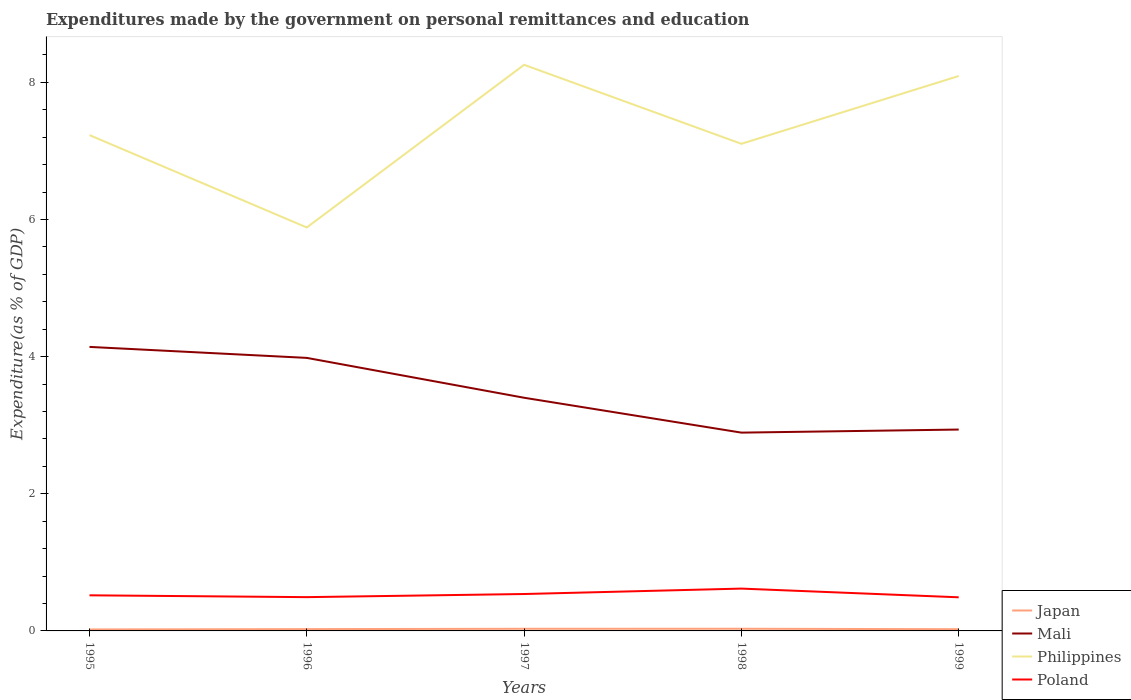How many different coloured lines are there?
Your response must be concise. 4. Does the line corresponding to Japan intersect with the line corresponding to Mali?
Make the answer very short. No. Across all years, what is the maximum expenditures made by the government on personal remittances and education in Philippines?
Keep it short and to the point. 5.88. What is the total expenditures made by the government on personal remittances and education in Philippines in the graph?
Your answer should be very brief. 0.13. What is the difference between the highest and the second highest expenditures made by the government on personal remittances and education in Mali?
Offer a terse response. 1.25. How many legend labels are there?
Your response must be concise. 4. What is the title of the graph?
Your response must be concise. Expenditures made by the government on personal remittances and education. What is the label or title of the X-axis?
Your answer should be very brief. Years. What is the label or title of the Y-axis?
Your response must be concise. Expenditure(as % of GDP). What is the Expenditure(as % of GDP) of Japan in 1995?
Provide a short and direct response. 0.02. What is the Expenditure(as % of GDP) of Mali in 1995?
Provide a short and direct response. 4.14. What is the Expenditure(as % of GDP) of Philippines in 1995?
Your response must be concise. 7.23. What is the Expenditure(as % of GDP) in Poland in 1995?
Ensure brevity in your answer.  0.52. What is the Expenditure(as % of GDP) of Japan in 1996?
Your response must be concise. 0.03. What is the Expenditure(as % of GDP) of Mali in 1996?
Ensure brevity in your answer.  3.98. What is the Expenditure(as % of GDP) in Philippines in 1996?
Ensure brevity in your answer.  5.88. What is the Expenditure(as % of GDP) of Poland in 1996?
Offer a very short reply. 0.49. What is the Expenditure(as % of GDP) of Japan in 1997?
Your answer should be very brief. 0.03. What is the Expenditure(as % of GDP) of Mali in 1997?
Provide a succinct answer. 3.4. What is the Expenditure(as % of GDP) in Philippines in 1997?
Offer a very short reply. 8.26. What is the Expenditure(as % of GDP) in Poland in 1997?
Give a very brief answer. 0.54. What is the Expenditure(as % of GDP) in Japan in 1998?
Provide a succinct answer. 0.03. What is the Expenditure(as % of GDP) in Mali in 1998?
Make the answer very short. 2.89. What is the Expenditure(as % of GDP) in Philippines in 1998?
Provide a short and direct response. 7.1. What is the Expenditure(as % of GDP) of Poland in 1998?
Your response must be concise. 0.62. What is the Expenditure(as % of GDP) in Japan in 1999?
Keep it short and to the point. 0.03. What is the Expenditure(as % of GDP) in Mali in 1999?
Your response must be concise. 2.94. What is the Expenditure(as % of GDP) in Philippines in 1999?
Provide a short and direct response. 8.09. What is the Expenditure(as % of GDP) in Poland in 1999?
Provide a short and direct response. 0.49. Across all years, what is the maximum Expenditure(as % of GDP) of Japan?
Give a very brief answer. 0.03. Across all years, what is the maximum Expenditure(as % of GDP) in Mali?
Your answer should be very brief. 4.14. Across all years, what is the maximum Expenditure(as % of GDP) of Philippines?
Offer a very short reply. 8.26. Across all years, what is the maximum Expenditure(as % of GDP) of Poland?
Your response must be concise. 0.62. Across all years, what is the minimum Expenditure(as % of GDP) of Japan?
Ensure brevity in your answer.  0.02. Across all years, what is the minimum Expenditure(as % of GDP) in Mali?
Keep it short and to the point. 2.89. Across all years, what is the minimum Expenditure(as % of GDP) of Philippines?
Give a very brief answer. 5.88. Across all years, what is the minimum Expenditure(as % of GDP) in Poland?
Provide a succinct answer. 0.49. What is the total Expenditure(as % of GDP) in Japan in the graph?
Provide a succinct answer. 0.14. What is the total Expenditure(as % of GDP) of Mali in the graph?
Give a very brief answer. 17.35. What is the total Expenditure(as % of GDP) of Philippines in the graph?
Provide a succinct answer. 36.57. What is the total Expenditure(as % of GDP) of Poland in the graph?
Your response must be concise. 2.66. What is the difference between the Expenditure(as % of GDP) of Japan in 1995 and that in 1996?
Your answer should be very brief. -0. What is the difference between the Expenditure(as % of GDP) of Mali in 1995 and that in 1996?
Your response must be concise. 0.16. What is the difference between the Expenditure(as % of GDP) in Philippines in 1995 and that in 1996?
Your answer should be compact. 1.35. What is the difference between the Expenditure(as % of GDP) in Poland in 1995 and that in 1996?
Give a very brief answer. 0.03. What is the difference between the Expenditure(as % of GDP) of Japan in 1995 and that in 1997?
Provide a succinct answer. -0.01. What is the difference between the Expenditure(as % of GDP) in Mali in 1995 and that in 1997?
Make the answer very short. 0.74. What is the difference between the Expenditure(as % of GDP) in Philippines in 1995 and that in 1997?
Make the answer very short. -1.03. What is the difference between the Expenditure(as % of GDP) of Poland in 1995 and that in 1997?
Your answer should be very brief. -0.02. What is the difference between the Expenditure(as % of GDP) in Japan in 1995 and that in 1998?
Make the answer very short. -0.01. What is the difference between the Expenditure(as % of GDP) in Mali in 1995 and that in 1998?
Your response must be concise. 1.25. What is the difference between the Expenditure(as % of GDP) of Philippines in 1995 and that in 1998?
Make the answer very short. 0.13. What is the difference between the Expenditure(as % of GDP) of Poland in 1995 and that in 1998?
Make the answer very short. -0.1. What is the difference between the Expenditure(as % of GDP) in Japan in 1995 and that in 1999?
Offer a very short reply. -0. What is the difference between the Expenditure(as % of GDP) of Mali in 1995 and that in 1999?
Provide a short and direct response. 1.21. What is the difference between the Expenditure(as % of GDP) in Philippines in 1995 and that in 1999?
Provide a short and direct response. -0.86. What is the difference between the Expenditure(as % of GDP) in Poland in 1995 and that in 1999?
Provide a short and direct response. 0.03. What is the difference between the Expenditure(as % of GDP) in Japan in 1996 and that in 1997?
Offer a very short reply. -0.01. What is the difference between the Expenditure(as % of GDP) in Mali in 1996 and that in 1997?
Keep it short and to the point. 0.58. What is the difference between the Expenditure(as % of GDP) in Philippines in 1996 and that in 1997?
Provide a succinct answer. -2.37. What is the difference between the Expenditure(as % of GDP) in Poland in 1996 and that in 1997?
Offer a very short reply. -0.05. What is the difference between the Expenditure(as % of GDP) of Japan in 1996 and that in 1998?
Offer a terse response. -0.01. What is the difference between the Expenditure(as % of GDP) of Mali in 1996 and that in 1998?
Give a very brief answer. 1.09. What is the difference between the Expenditure(as % of GDP) of Philippines in 1996 and that in 1998?
Make the answer very short. -1.22. What is the difference between the Expenditure(as % of GDP) of Poland in 1996 and that in 1998?
Keep it short and to the point. -0.12. What is the difference between the Expenditure(as % of GDP) of Japan in 1996 and that in 1999?
Your answer should be very brief. 0. What is the difference between the Expenditure(as % of GDP) of Mali in 1996 and that in 1999?
Give a very brief answer. 1.05. What is the difference between the Expenditure(as % of GDP) of Philippines in 1996 and that in 1999?
Ensure brevity in your answer.  -2.21. What is the difference between the Expenditure(as % of GDP) in Poland in 1996 and that in 1999?
Make the answer very short. 0. What is the difference between the Expenditure(as % of GDP) in Japan in 1997 and that in 1998?
Give a very brief answer. -0. What is the difference between the Expenditure(as % of GDP) of Mali in 1997 and that in 1998?
Ensure brevity in your answer.  0.51. What is the difference between the Expenditure(as % of GDP) in Philippines in 1997 and that in 1998?
Your answer should be compact. 1.15. What is the difference between the Expenditure(as % of GDP) in Poland in 1997 and that in 1998?
Your response must be concise. -0.08. What is the difference between the Expenditure(as % of GDP) of Japan in 1997 and that in 1999?
Your response must be concise. 0.01. What is the difference between the Expenditure(as % of GDP) of Mali in 1997 and that in 1999?
Your answer should be compact. 0.46. What is the difference between the Expenditure(as % of GDP) of Philippines in 1997 and that in 1999?
Ensure brevity in your answer.  0.16. What is the difference between the Expenditure(as % of GDP) in Poland in 1997 and that in 1999?
Provide a short and direct response. 0.05. What is the difference between the Expenditure(as % of GDP) in Japan in 1998 and that in 1999?
Your answer should be very brief. 0.01. What is the difference between the Expenditure(as % of GDP) in Mali in 1998 and that in 1999?
Your response must be concise. -0.04. What is the difference between the Expenditure(as % of GDP) of Philippines in 1998 and that in 1999?
Your answer should be very brief. -0.99. What is the difference between the Expenditure(as % of GDP) of Poland in 1998 and that in 1999?
Give a very brief answer. 0.13. What is the difference between the Expenditure(as % of GDP) of Japan in 1995 and the Expenditure(as % of GDP) of Mali in 1996?
Make the answer very short. -3.96. What is the difference between the Expenditure(as % of GDP) of Japan in 1995 and the Expenditure(as % of GDP) of Philippines in 1996?
Your response must be concise. -5.86. What is the difference between the Expenditure(as % of GDP) in Japan in 1995 and the Expenditure(as % of GDP) in Poland in 1996?
Offer a terse response. -0.47. What is the difference between the Expenditure(as % of GDP) of Mali in 1995 and the Expenditure(as % of GDP) of Philippines in 1996?
Give a very brief answer. -1.74. What is the difference between the Expenditure(as % of GDP) of Mali in 1995 and the Expenditure(as % of GDP) of Poland in 1996?
Provide a succinct answer. 3.65. What is the difference between the Expenditure(as % of GDP) of Philippines in 1995 and the Expenditure(as % of GDP) of Poland in 1996?
Make the answer very short. 6.74. What is the difference between the Expenditure(as % of GDP) of Japan in 1995 and the Expenditure(as % of GDP) of Mali in 1997?
Your answer should be very brief. -3.38. What is the difference between the Expenditure(as % of GDP) of Japan in 1995 and the Expenditure(as % of GDP) of Philippines in 1997?
Your response must be concise. -8.24. What is the difference between the Expenditure(as % of GDP) of Japan in 1995 and the Expenditure(as % of GDP) of Poland in 1997?
Provide a short and direct response. -0.52. What is the difference between the Expenditure(as % of GDP) of Mali in 1995 and the Expenditure(as % of GDP) of Philippines in 1997?
Offer a terse response. -4.11. What is the difference between the Expenditure(as % of GDP) of Mali in 1995 and the Expenditure(as % of GDP) of Poland in 1997?
Offer a very short reply. 3.6. What is the difference between the Expenditure(as % of GDP) in Philippines in 1995 and the Expenditure(as % of GDP) in Poland in 1997?
Offer a very short reply. 6.69. What is the difference between the Expenditure(as % of GDP) of Japan in 1995 and the Expenditure(as % of GDP) of Mali in 1998?
Offer a terse response. -2.87. What is the difference between the Expenditure(as % of GDP) in Japan in 1995 and the Expenditure(as % of GDP) in Philippines in 1998?
Ensure brevity in your answer.  -7.08. What is the difference between the Expenditure(as % of GDP) of Japan in 1995 and the Expenditure(as % of GDP) of Poland in 1998?
Provide a succinct answer. -0.6. What is the difference between the Expenditure(as % of GDP) of Mali in 1995 and the Expenditure(as % of GDP) of Philippines in 1998?
Your answer should be compact. -2.96. What is the difference between the Expenditure(as % of GDP) of Mali in 1995 and the Expenditure(as % of GDP) of Poland in 1998?
Provide a short and direct response. 3.53. What is the difference between the Expenditure(as % of GDP) of Philippines in 1995 and the Expenditure(as % of GDP) of Poland in 1998?
Your answer should be compact. 6.61. What is the difference between the Expenditure(as % of GDP) in Japan in 1995 and the Expenditure(as % of GDP) in Mali in 1999?
Provide a succinct answer. -2.92. What is the difference between the Expenditure(as % of GDP) in Japan in 1995 and the Expenditure(as % of GDP) in Philippines in 1999?
Your answer should be very brief. -8.07. What is the difference between the Expenditure(as % of GDP) in Japan in 1995 and the Expenditure(as % of GDP) in Poland in 1999?
Keep it short and to the point. -0.47. What is the difference between the Expenditure(as % of GDP) in Mali in 1995 and the Expenditure(as % of GDP) in Philippines in 1999?
Provide a succinct answer. -3.95. What is the difference between the Expenditure(as % of GDP) of Mali in 1995 and the Expenditure(as % of GDP) of Poland in 1999?
Your answer should be compact. 3.65. What is the difference between the Expenditure(as % of GDP) in Philippines in 1995 and the Expenditure(as % of GDP) in Poland in 1999?
Ensure brevity in your answer.  6.74. What is the difference between the Expenditure(as % of GDP) in Japan in 1996 and the Expenditure(as % of GDP) in Mali in 1997?
Offer a terse response. -3.37. What is the difference between the Expenditure(as % of GDP) in Japan in 1996 and the Expenditure(as % of GDP) in Philippines in 1997?
Make the answer very short. -8.23. What is the difference between the Expenditure(as % of GDP) in Japan in 1996 and the Expenditure(as % of GDP) in Poland in 1997?
Ensure brevity in your answer.  -0.51. What is the difference between the Expenditure(as % of GDP) of Mali in 1996 and the Expenditure(as % of GDP) of Philippines in 1997?
Provide a short and direct response. -4.27. What is the difference between the Expenditure(as % of GDP) in Mali in 1996 and the Expenditure(as % of GDP) in Poland in 1997?
Keep it short and to the point. 3.44. What is the difference between the Expenditure(as % of GDP) of Philippines in 1996 and the Expenditure(as % of GDP) of Poland in 1997?
Offer a very short reply. 5.35. What is the difference between the Expenditure(as % of GDP) of Japan in 1996 and the Expenditure(as % of GDP) of Mali in 1998?
Your response must be concise. -2.87. What is the difference between the Expenditure(as % of GDP) in Japan in 1996 and the Expenditure(as % of GDP) in Philippines in 1998?
Provide a short and direct response. -7.08. What is the difference between the Expenditure(as % of GDP) of Japan in 1996 and the Expenditure(as % of GDP) of Poland in 1998?
Your answer should be very brief. -0.59. What is the difference between the Expenditure(as % of GDP) of Mali in 1996 and the Expenditure(as % of GDP) of Philippines in 1998?
Ensure brevity in your answer.  -3.12. What is the difference between the Expenditure(as % of GDP) of Mali in 1996 and the Expenditure(as % of GDP) of Poland in 1998?
Offer a very short reply. 3.36. What is the difference between the Expenditure(as % of GDP) of Philippines in 1996 and the Expenditure(as % of GDP) of Poland in 1998?
Your answer should be very brief. 5.27. What is the difference between the Expenditure(as % of GDP) in Japan in 1996 and the Expenditure(as % of GDP) in Mali in 1999?
Give a very brief answer. -2.91. What is the difference between the Expenditure(as % of GDP) of Japan in 1996 and the Expenditure(as % of GDP) of Philippines in 1999?
Ensure brevity in your answer.  -8.07. What is the difference between the Expenditure(as % of GDP) of Japan in 1996 and the Expenditure(as % of GDP) of Poland in 1999?
Provide a short and direct response. -0.46. What is the difference between the Expenditure(as % of GDP) in Mali in 1996 and the Expenditure(as % of GDP) in Philippines in 1999?
Make the answer very short. -4.11. What is the difference between the Expenditure(as % of GDP) of Mali in 1996 and the Expenditure(as % of GDP) of Poland in 1999?
Offer a very short reply. 3.49. What is the difference between the Expenditure(as % of GDP) of Philippines in 1996 and the Expenditure(as % of GDP) of Poland in 1999?
Offer a very short reply. 5.39. What is the difference between the Expenditure(as % of GDP) of Japan in 1997 and the Expenditure(as % of GDP) of Mali in 1998?
Make the answer very short. -2.86. What is the difference between the Expenditure(as % of GDP) of Japan in 1997 and the Expenditure(as % of GDP) of Philippines in 1998?
Offer a terse response. -7.07. What is the difference between the Expenditure(as % of GDP) of Japan in 1997 and the Expenditure(as % of GDP) of Poland in 1998?
Offer a terse response. -0.59. What is the difference between the Expenditure(as % of GDP) in Mali in 1997 and the Expenditure(as % of GDP) in Philippines in 1998?
Make the answer very short. -3.7. What is the difference between the Expenditure(as % of GDP) in Mali in 1997 and the Expenditure(as % of GDP) in Poland in 1998?
Your answer should be very brief. 2.78. What is the difference between the Expenditure(as % of GDP) of Philippines in 1997 and the Expenditure(as % of GDP) of Poland in 1998?
Your response must be concise. 7.64. What is the difference between the Expenditure(as % of GDP) of Japan in 1997 and the Expenditure(as % of GDP) of Mali in 1999?
Offer a very short reply. -2.91. What is the difference between the Expenditure(as % of GDP) of Japan in 1997 and the Expenditure(as % of GDP) of Philippines in 1999?
Provide a succinct answer. -8.06. What is the difference between the Expenditure(as % of GDP) of Japan in 1997 and the Expenditure(as % of GDP) of Poland in 1999?
Make the answer very short. -0.46. What is the difference between the Expenditure(as % of GDP) of Mali in 1997 and the Expenditure(as % of GDP) of Philippines in 1999?
Give a very brief answer. -4.69. What is the difference between the Expenditure(as % of GDP) in Mali in 1997 and the Expenditure(as % of GDP) in Poland in 1999?
Ensure brevity in your answer.  2.91. What is the difference between the Expenditure(as % of GDP) in Philippines in 1997 and the Expenditure(as % of GDP) in Poland in 1999?
Make the answer very short. 7.77. What is the difference between the Expenditure(as % of GDP) in Japan in 1998 and the Expenditure(as % of GDP) in Mali in 1999?
Provide a short and direct response. -2.91. What is the difference between the Expenditure(as % of GDP) of Japan in 1998 and the Expenditure(as % of GDP) of Philippines in 1999?
Give a very brief answer. -8.06. What is the difference between the Expenditure(as % of GDP) of Japan in 1998 and the Expenditure(as % of GDP) of Poland in 1999?
Your answer should be compact. -0.46. What is the difference between the Expenditure(as % of GDP) of Mali in 1998 and the Expenditure(as % of GDP) of Philippines in 1999?
Provide a short and direct response. -5.2. What is the difference between the Expenditure(as % of GDP) of Mali in 1998 and the Expenditure(as % of GDP) of Poland in 1999?
Make the answer very short. 2.4. What is the difference between the Expenditure(as % of GDP) in Philippines in 1998 and the Expenditure(as % of GDP) in Poland in 1999?
Keep it short and to the point. 6.61. What is the average Expenditure(as % of GDP) of Japan per year?
Provide a succinct answer. 0.03. What is the average Expenditure(as % of GDP) in Mali per year?
Your answer should be very brief. 3.47. What is the average Expenditure(as % of GDP) of Philippines per year?
Your response must be concise. 7.31. What is the average Expenditure(as % of GDP) of Poland per year?
Your answer should be compact. 0.53. In the year 1995, what is the difference between the Expenditure(as % of GDP) in Japan and Expenditure(as % of GDP) in Mali?
Offer a terse response. -4.12. In the year 1995, what is the difference between the Expenditure(as % of GDP) of Japan and Expenditure(as % of GDP) of Philippines?
Your response must be concise. -7.21. In the year 1995, what is the difference between the Expenditure(as % of GDP) in Japan and Expenditure(as % of GDP) in Poland?
Give a very brief answer. -0.5. In the year 1995, what is the difference between the Expenditure(as % of GDP) of Mali and Expenditure(as % of GDP) of Philippines?
Your response must be concise. -3.09. In the year 1995, what is the difference between the Expenditure(as % of GDP) of Mali and Expenditure(as % of GDP) of Poland?
Ensure brevity in your answer.  3.62. In the year 1995, what is the difference between the Expenditure(as % of GDP) of Philippines and Expenditure(as % of GDP) of Poland?
Keep it short and to the point. 6.71. In the year 1996, what is the difference between the Expenditure(as % of GDP) in Japan and Expenditure(as % of GDP) in Mali?
Offer a terse response. -3.96. In the year 1996, what is the difference between the Expenditure(as % of GDP) in Japan and Expenditure(as % of GDP) in Philippines?
Ensure brevity in your answer.  -5.86. In the year 1996, what is the difference between the Expenditure(as % of GDP) of Japan and Expenditure(as % of GDP) of Poland?
Offer a very short reply. -0.47. In the year 1996, what is the difference between the Expenditure(as % of GDP) in Mali and Expenditure(as % of GDP) in Philippines?
Ensure brevity in your answer.  -1.9. In the year 1996, what is the difference between the Expenditure(as % of GDP) in Mali and Expenditure(as % of GDP) in Poland?
Make the answer very short. 3.49. In the year 1996, what is the difference between the Expenditure(as % of GDP) in Philippines and Expenditure(as % of GDP) in Poland?
Make the answer very short. 5.39. In the year 1997, what is the difference between the Expenditure(as % of GDP) of Japan and Expenditure(as % of GDP) of Mali?
Keep it short and to the point. -3.37. In the year 1997, what is the difference between the Expenditure(as % of GDP) of Japan and Expenditure(as % of GDP) of Philippines?
Provide a short and direct response. -8.23. In the year 1997, what is the difference between the Expenditure(as % of GDP) of Japan and Expenditure(as % of GDP) of Poland?
Make the answer very short. -0.51. In the year 1997, what is the difference between the Expenditure(as % of GDP) of Mali and Expenditure(as % of GDP) of Philippines?
Give a very brief answer. -4.86. In the year 1997, what is the difference between the Expenditure(as % of GDP) of Mali and Expenditure(as % of GDP) of Poland?
Offer a very short reply. 2.86. In the year 1997, what is the difference between the Expenditure(as % of GDP) of Philippines and Expenditure(as % of GDP) of Poland?
Your response must be concise. 7.72. In the year 1998, what is the difference between the Expenditure(as % of GDP) in Japan and Expenditure(as % of GDP) in Mali?
Make the answer very short. -2.86. In the year 1998, what is the difference between the Expenditure(as % of GDP) in Japan and Expenditure(as % of GDP) in Philippines?
Offer a terse response. -7.07. In the year 1998, what is the difference between the Expenditure(as % of GDP) of Japan and Expenditure(as % of GDP) of Poland?
Ensure brevity in your answer.  -0.59. In the year 1998, what is the difference between the Expenditure(as % of GDP) in Mali and Expenditure(as % of GDP) in Philippines?
Your answer should be very brief. -4.21. In the year 1998, what is the difference between the Expenditure(as % of GDP) in Mali and Expenditure(as % of GDP) in Poland?
Offer a terse response. 2.27. In the year 1998, what is the difference between the Expenditure(as % of GDP) in Philippines and Expenditure(as % of GDP) in Poland?
Your answer should be very brief. 6.49. In the year 1999, what is the difference between the Expenditure(as % of GDP) of Japan and Expenditure(as % of GDP) of Mali?
Offer a terse response. -2.91. In the year 1999, what is the difference between the Expenditure(as % of GDP) in Japan and Expenditure(as % of GDP) in Philippines?
Your answer should be compact. -8.07. In the year 1999, what is the difference between the Expenditure(as % of GDP) of Japan and Expenditure(as % of GDP) of Poland?
Ensure brevity in your answer.  -0.47. In the year 1999, what is the difference between the Expenditure(as % of GDP) in Mali and Expenditure(as % of GDP) in Philippines?
Make the answer very short. -5.16. In the year 1999, what is the difference between the Expenditure(as % of GDP) in Mali and Expenditure(as % of GDP) in Poland?
Provide a short and direct response. 2.45. In the year 1999, what is the difference between the Expenditure(as % of GDP) of Philippines and Expenditure(as % of GDP) of Poland?
Ensure brevity in your answer.  7.6. What is the ratio of the Expenditure(as % of GDP) of Japan in 1995 to that in 1996?
Your response must be concise. 0.83. What is the ratio of the Expenditure(as % of GDP) in Mali in 1995 to that in 1996?
Your answer should be compact. 1.04. What is the ratio of the Expenditure(as % of GDP) of Philippines in 1995 to that in 1996?
Your answer should be compact. 1.23. What is the ratio of the Expenditure(as % of GDP) of Poland in 1995 to that in 1996?
Offer a terse response. 1.05. What is the ratio of the Expenditure(as % of GDP) in Japan in 1995 to that in 1997?
Keep it short and to the point. 0.69. What is the ratio of the Expenditure(as % of GDP) of Mali in 1995 to that in 1997?
Give a very brief answer. 1.22. What is the ratio of the Expenditure(as % of GDP) of Philippines in 1995 to that in 1997?
Your answer should be very brief. 0.88. What is the ratio of the Expenditure(as % of GDP) in Poland in 1995 to that in 1997?
Offer a very short reply. 0.96. What is the ratio of the Expenditure(as % of GDP) in Japan in 1995 to that in 1998?
Your response must be concise. 0.68. What is the ratio of the Expenditure(as % of GDP) in Mali in 1995 to that in 1998?
Your answer should be very brief. 1.43. What is the ratio of the Expenditure(as % of GDP) of Philippines in 1995 to that in 1998?
Keep it short and to the point. 1.02. What is the ratio of the Expenditure(as % of GDP) in Poland in 1995 to that in 1998?
Offer a terse response. 0.84. What is the ratio of the Expenditure(as % of GDP) of Japan in 1995 to that in 1999?
Make the answer very short. 0.86. What is the ratio of the Expenditure(as % of GDP) in Mali in 1995 to that in 1999?
Keep it short and to the point. 1.41. What is the ratio of the Expenditure(as % of GDP) of Philippines in 1995 to that in 1999?
Your response must be concise. 0.89. What is the ratio of the Expenditure(as % of GDP) of Poland in 1995 to that in 1999?
Offer a terse response. 1.06. What is the ratio of the Expenditure(as % of GDP) in Japan in 1996 to that in 1997?
Offer a very short reply. 0.84. What is the ratio of the Expenditure(as % of GDP) of Mali in 1996 to that in 1997?
Provide a succinct answer. 1.17. What is the ratio of the Expenditure(as % of GDP) of Philippines in 1996 to that in 1997?
Offer a terse response. 0.71. What is the ratio of the Expenditure(as % of GDP) of Poland in 1996 to that in 1997?
Make the answer very short. 0.92. What is the ratio of the Expenditure(as % of GDP) of Japan in 1996 to that in 1998?
Your response must be concise. 0.82. What is the ratio of the Expenditure(as % of GDP) in Mali in 1996 to that in 1998?
Your answer should be compact. 1.38. What is the ratio of the Expenditure(as % of GDP) in Philippines in 1996 to that in 1998?
Offer a terse response. 0.83. What is the ratio of the Expenditure(as % of GDP) in Poland in 1996 to that in 1998?
Provide a succinct answer. 0.8. What is the ratio of the Expenditure(as % of GDP) of Japan in 1996 to that in 1999?
Ensure brevity in your answer.  1.04. What is the ratio of the Expenditure(as % of GDP) of Mali in 1996 to that in 1999?
Offer a terse response. 1.36. What is the ratio of the Expenditure(as % of GDP) in Philippines in 1996 to that in 1999?
Ensure brevity in your answer.  0.73. What is the ratio of the Expenditure(as % of GDP) of Poland in 1996 to that in 1999?
Keep it short and to the point. 1. What is the ratio of the Expenditure(as % of GDP) in Mali in 1997 to that in 1998?
Your response must be concise. 1.18. What is the ratio of the Expenditure(as % of GDP) of Philippines in 1997 to that in 1998?
Make the answer very short. 1.16. What is the ratio of the Expenditure(as % of GDP) in Poland in 1997 to that in 1998?
Make the answer very short. 0.87. What is the ratio of the Expenditure(as % of GDP) of Japan in 1997 to that in 1999?
Keep it short and to the point. 1.24. What is the ratio of the Expenditure(as % of GDP) in Mali in 1997 to that in 1999?
Make the answer very short. 1.16. What is the ratio of the Expenditure(as % of GDP) in Philippines in 1997 to that in 1999?
Provide a succinct answer. 1.02. What is the ratio of the Expenditure(as % of GDP) of Poland in 1997 to that in 1999?
Offer a very short reply. 1.1. What is the ratio of the Expenditure(as % of GDP) of Japan in 1998 to that in 1999?
Provide a short and direct response. 1.26. What is the ratio of the Expenditure(as % of GDP) of Mali in 1998 to that in 1999?
Provide a succinct answer. 0.98. What is the ratio of the Expenditure(as % of GDP) of Philippines in 1998 to that in 1999?
Offer a terse response. 0.88. What is the ratio of the Expenditure(as % of GDP) of Poland in 1998 to that in 1999?
Keep it short and to the point. 1.26. What is the difference between the highest and the second highest Expenditure(as % of GDP) in Japan?
Offer a terse response. 0. What is the difference between the highest and the second highest Expenditure(as % of GDP) in Mali?
Offer a very short reply. 0.16. What is the difference between the highest and the second highest Expenditure(as % of GDP) of Philippines?
Give a very brief answer. 0.16. What is the difference between the highest and the second highest Expenditure(as % of GDP) of Poland?
Offer a terse response. 0.08. What is the difference between the highest and the lowest Expenditure(as % of GDP) of Japan?
Ensure brevity in your answer.  0.01. What is the difference between the highest and the lowest Expenditure(as % of GDP) in Mali?
Offer a very short reply. 1.25. What is the difference between the highest and the lowest Expenditure(as % of GDP) in Philippines?
Provide a short and direct response. 2.37. What is the difference between the highest and the lowest Expenditure(as % of GDP) of Poland?
Ensure brevity in your answer.  0.13. 